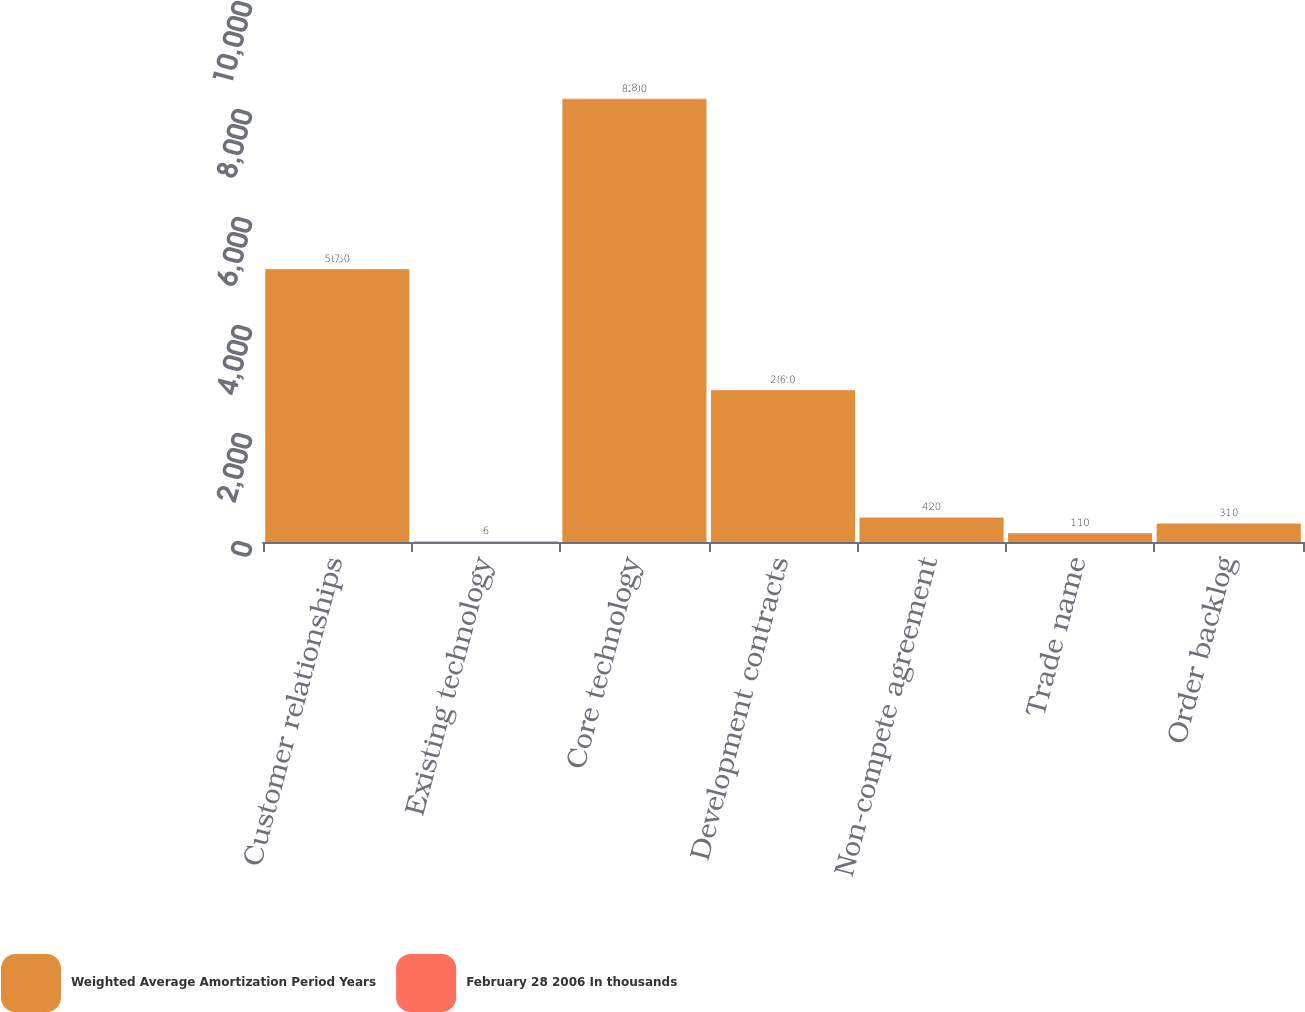<chart> <loc_0><loc_0><loc_500><loc_500><stacked_bar_chart><ecel><fcel>Customer relationships<fcel>Existing technology<fcel>Core technology<fcel>Development contracts<fcel>Non-compete agreement<fcel>Trade name<fcel>Order backlog<nl><fcel>Weighted Average Amortization Period Years<fcel>5050<fcel>8<fcel>8200<fcel>2810<fcel>450<fcel>160<fcel>340<nl><fcel>February 28 2006 In thousands<fcel>7<fcel>6<fcel>8<fcel>6<fcel>2<fcel>1<fcel>1<nl></chart> 